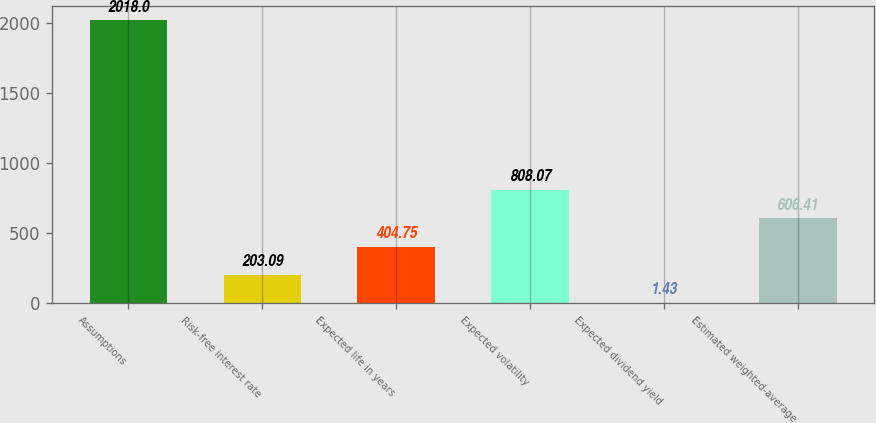Convert chart to OTSL. <chart><loc_0><loc_0><loc_500><loc_500><bar_chart><fcel>Assumptions<fcel>Risk-free interest rate<fcel>Expected life in years<fcel>Expected volatility<fcel>Expected dividend yield<fcel>Estimated weighted-average<nl><fcel>2018<fcel>203.09<fcel>404.75<fcel>808.07<fcel>1.43<fcel>606.41<nl></chart> 